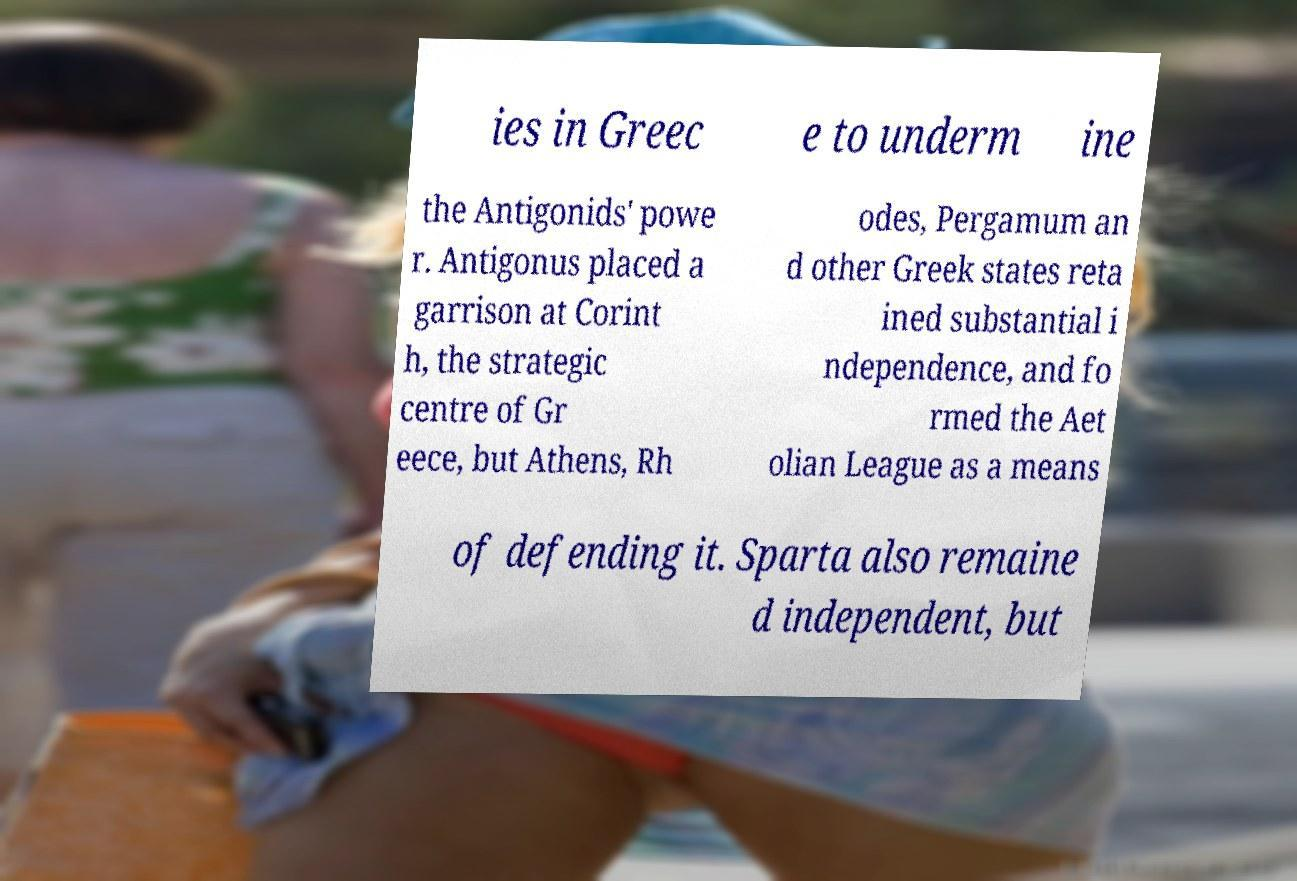Please read and relay the text visible in this image. What does it say? ies in Greec e to underm ine the Antigonids' powe r. Antigonus placed a garrison at Corint h, the strategic centre of Gr eece, but Athens, Rh odes, Pergamum an d other Greek states reta ined substantial i ndependence, and fo rmed the Aet olian League as a means of defending it. Sparta also remaine d independent, but 